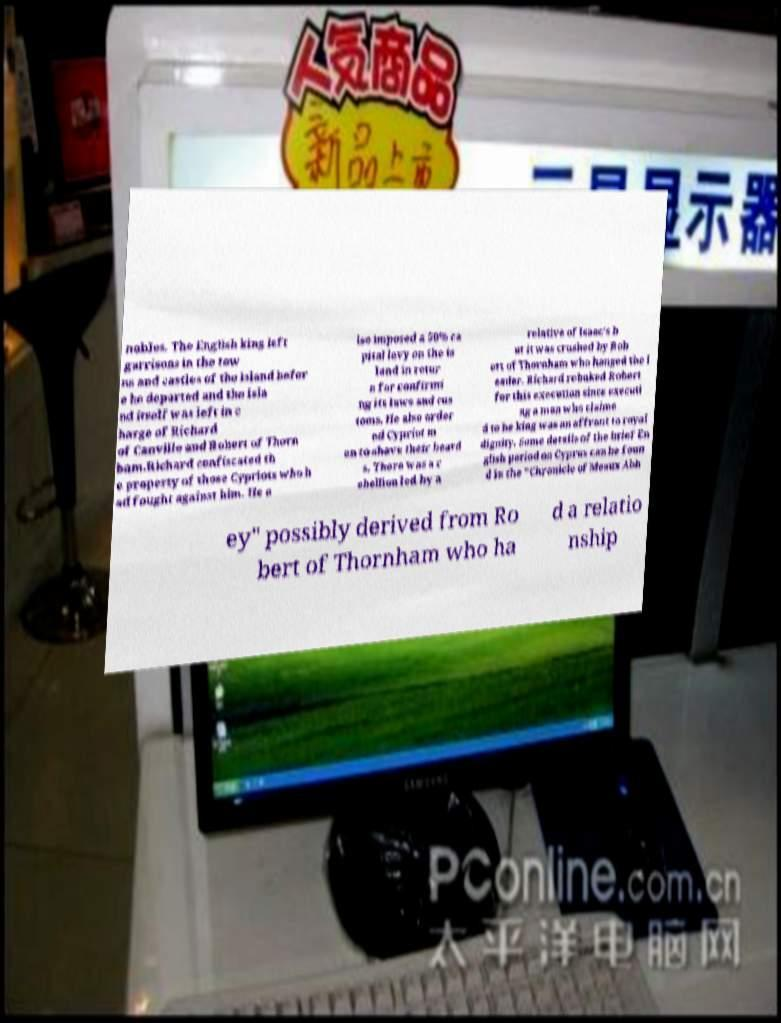Please identify and transcribe the text found in this image. nobles. The English king left garrisons in the tow ns and castles of the island befor e he departed and the isla nd itself was left in c harge of Richard of Canville and Robert of Thorn ham.Richard confiscated th e property of those Cypriots who h ad fought against him. He a lso imposed a 50% ca pital levy on the is land in retur n for confirmi ng its laws and cus toms. He also order ed Cypriot m en to shave their beard s. There was a r ebellion led by a relative of Isaac's b ut it was crushed by Rob ert of Thornham who hanged the l eader. Richard rebuked Robert for this execution since executi ng a man who claime d to be king was an affront to royal dignity. Some details of the brief En glish period on Cyprus can be foun d in the "Chronicle of Meaux Abb ey" possibly derived from Ro bert of Thornham who ha d a relatio nship 